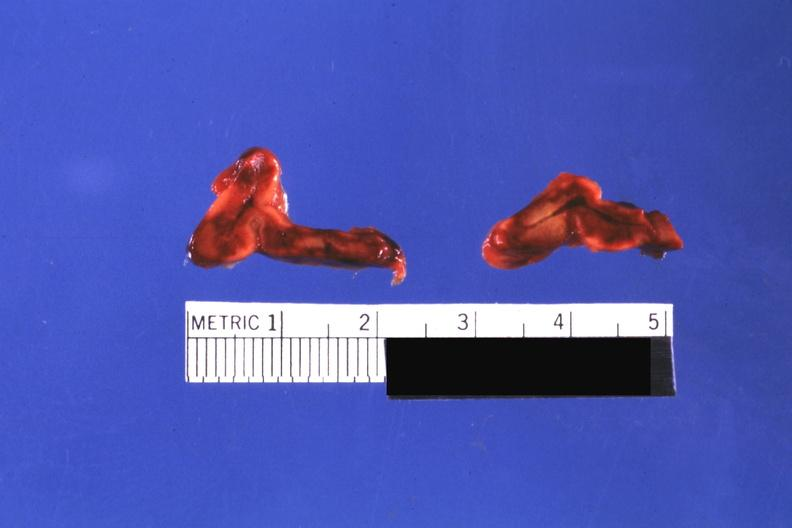where does this belong to?
Answer the question using a single word or phrase. Endocrine system 